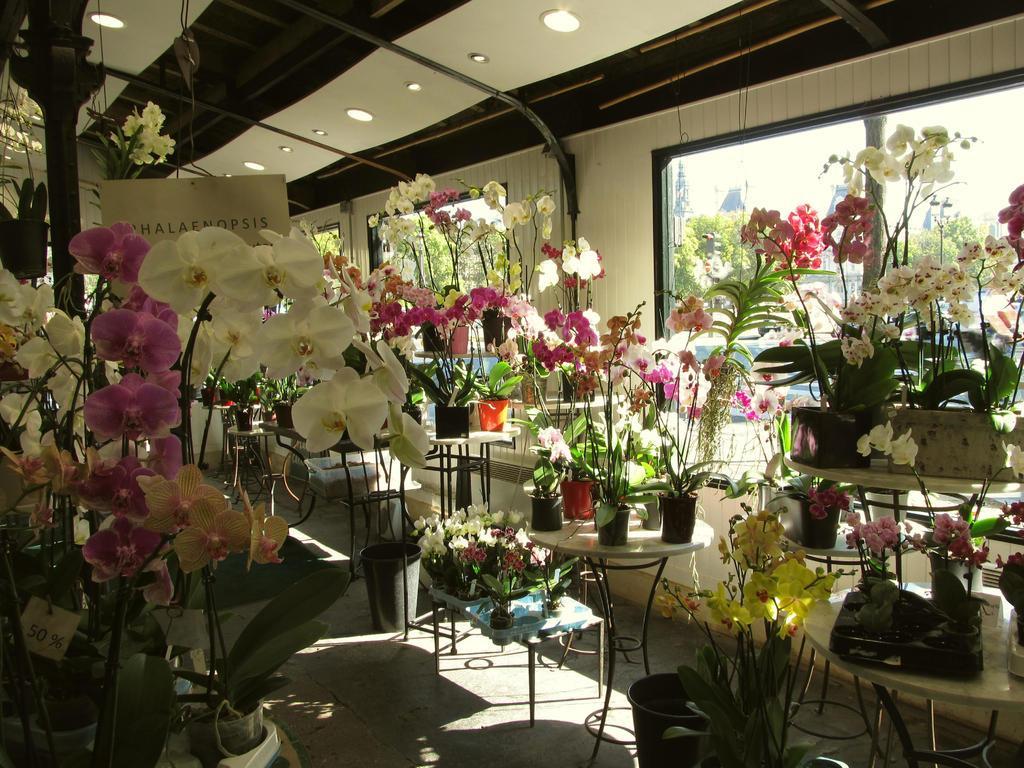Describe this image in one or two sentences. In this picture there are different types of flower pots, which are placed on the tables in the image and there are lamps on the roof at the tops side of the image and there are windows in the image and there are buildings and trees outside the windows. 